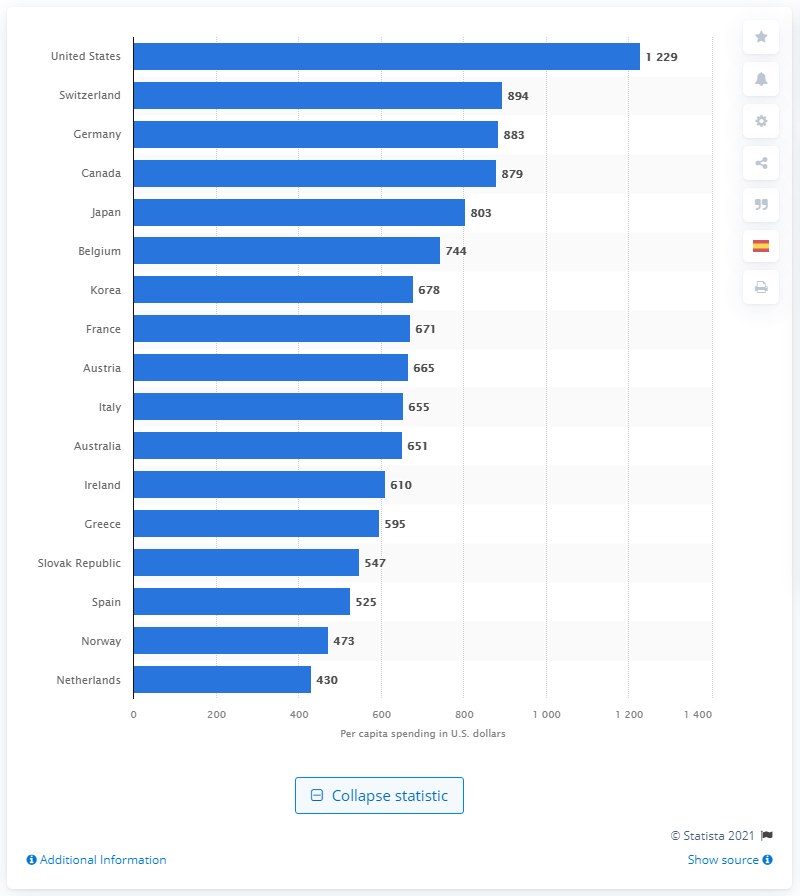Mention a couple of crucial points in this snapshot. According to data as of 2019, the per capita pharmaceutical spending in Canada was 879 dollars. 